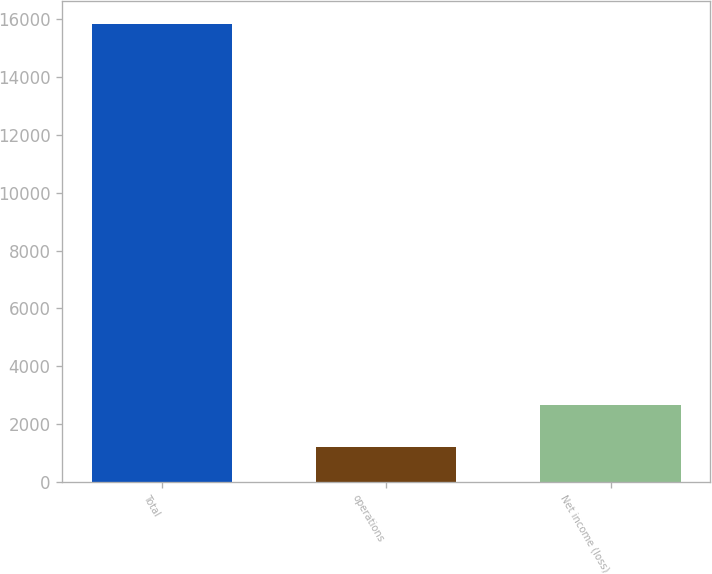<chart> <loc_0><loc_0><loc_500><loc_500><bar_chart><fcel>Total<fcel>operations<fcel>Net income (loss)<nl><fcel>15832<fcel>1181<fcel>2646.1<nl></chart> 